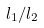<formula> <loc_0><loc_0><loc_500><loc_500>l _ { 1 } / l _ { 2 }</formula> 